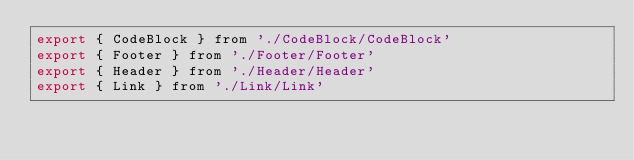Convert code to text. <code><loc_0><loc_0><loc_500><loc_500><_JavaScript_>export { CodeBlock } from './CodeBlock/CodeBlock'
export { Footer } from './Footer/Footer'
export { Header } from './Header/Header'
export { Link } from './Link/Link'
</code> 